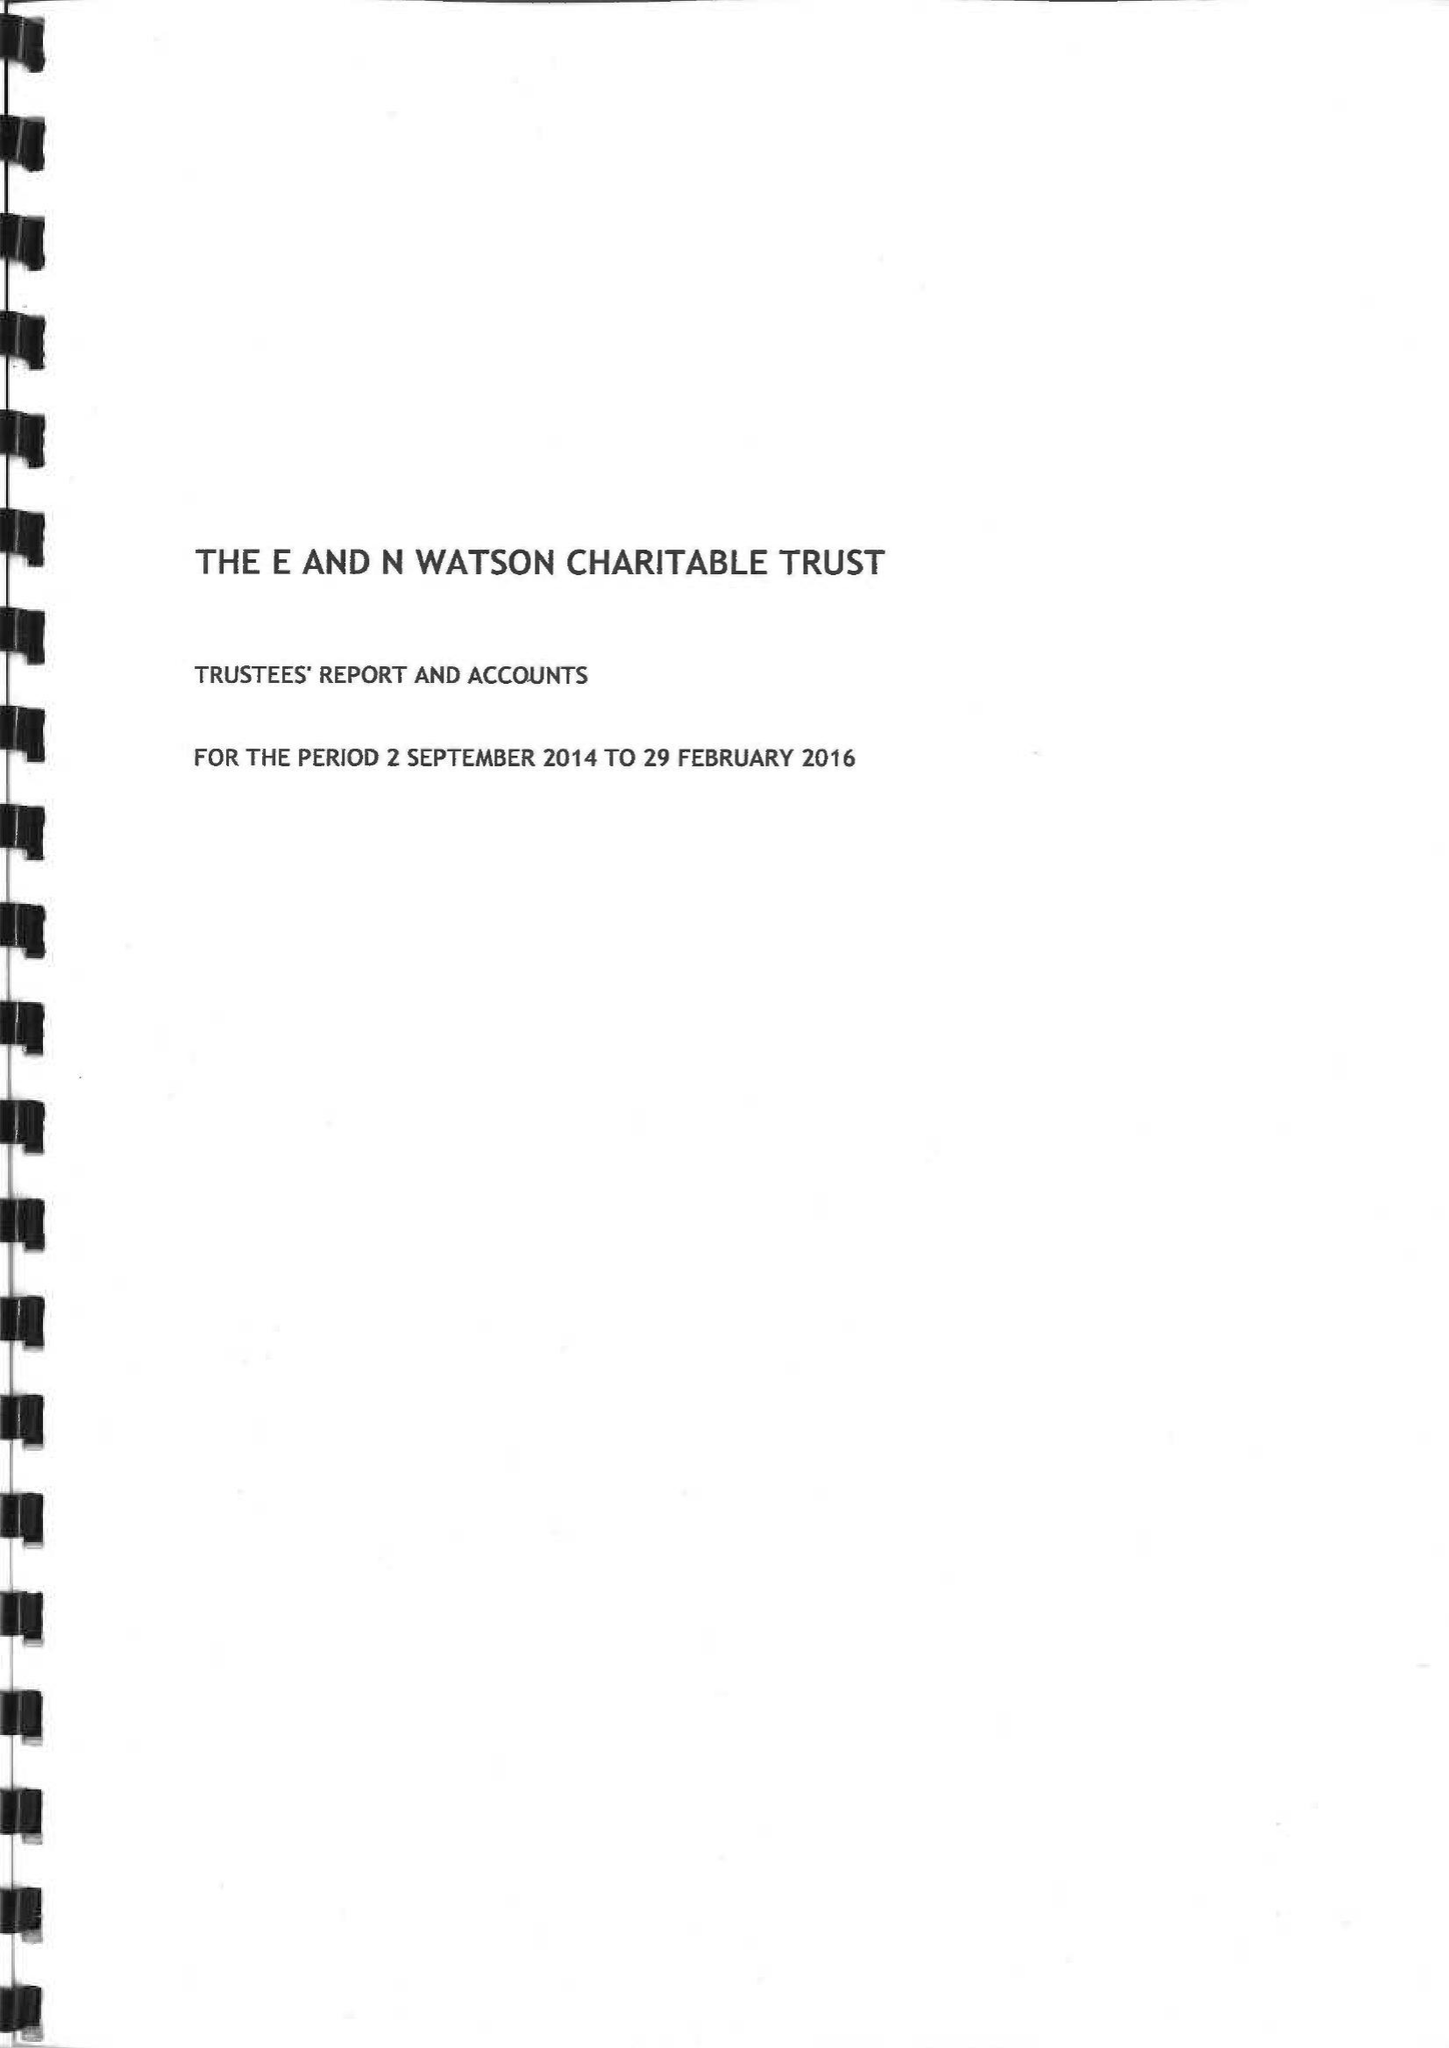What is the value for the income_annually_in_british_pounds?
Answer the question using a single word or phrase. 1093709.00 